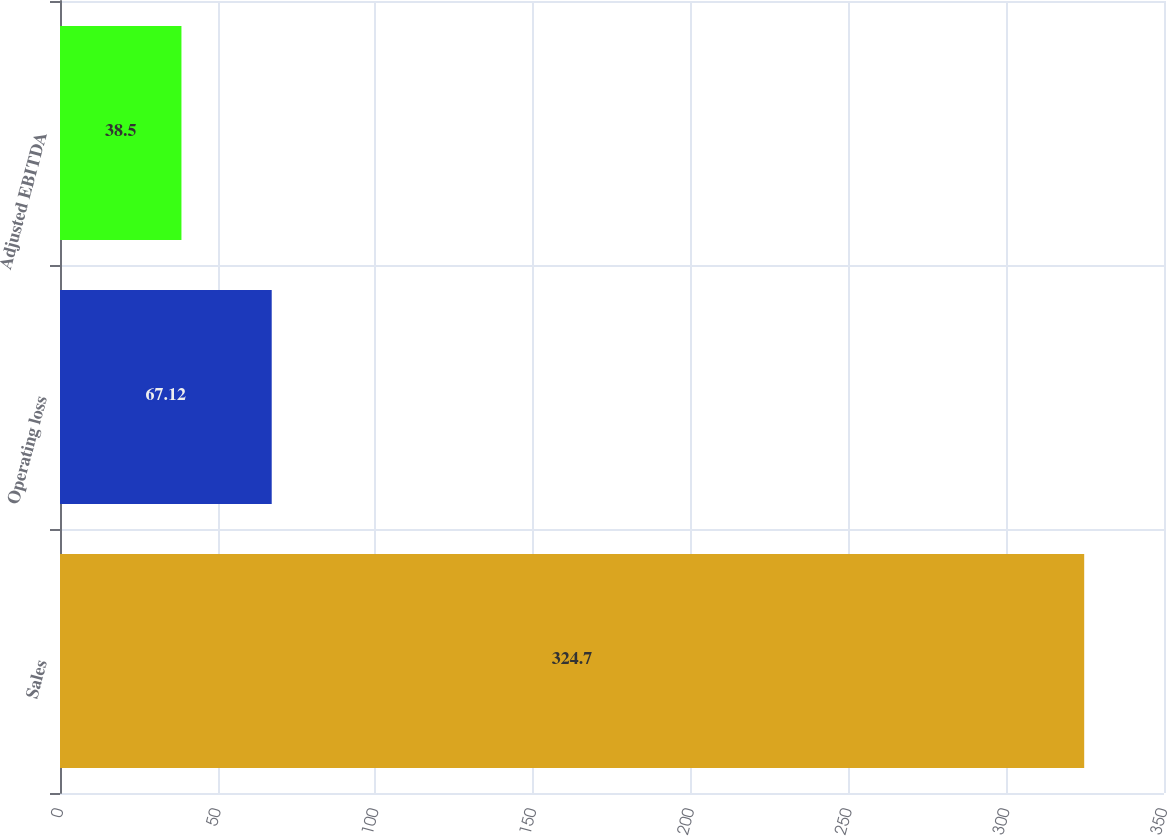<chart> <loc_0><loc_0><loc_500><loc_500><bar_chart><fcel>Sales<fcel>Operating loss<fcel>Adjusted EBITDA<nl><fcel>324.7<fcel>67.12<fcel>38.5<nl></chart> 